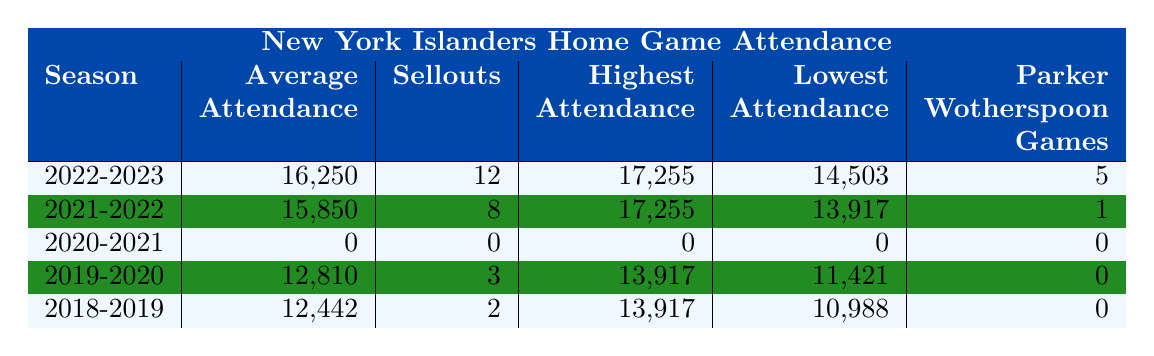What was the highest attendance at a New York Islanders home game over the last 5 seasons? By looking at the "Highest Attendance" column, the highest value listed is 17,255, which occurs in both the 2022-2023 and 2021-2022 seasons.
Answer: 17,255 In which season did the New York Islanders have the lowest average attendance? The "Average Attendance" column shows the values 16,250, 15,850, 0, 12,810, and 12,442. The lowest average attendance is 0 in the 2020-2021 season.
Answer: 2020-2021 How many sellouts did the Islanders achieve in the 2022-2023 season? The "Sellouts" column for the 2022-2023 season indicates there were 12 sellouts.
Answer: 12 What is the difference between the highest and lowest attendance figures in the 2019-2020 season? The "Highest Attendance" for 2019-2020 is 13,917 and the "Lowest Attendance" is 11,421. The difference is 13,917 - 11,421 = 2,496.
Answer: 2,496 Did the average attendance increase or decrease from the 2018-2019 season to the 2019-2020 season? In the 2018-2019 season, the average attendance was 12,442, while in the 2019-2020 season it decreased to 12,810. Since 12,810 is greater than 12,442, it decreased.
Answer: Decrease How many games did Parker Wotherspoon play in the seasons that recorded attendance? Summing the "Parker Wotherspoon Games" column for the seasons with attendance (2022-2023, 2021-2022, 2019-2020, and 2018-2019), we find 5 + 1 + 0 + 0 = 6 games.
Answer: 6 What was the average attendance across the five seasons? To find the average attendance, we calculate the total based on available data: (16,250 + 15,850 + 0 + 12,810 + 12,442) = 57,352. There are 4 instances (excluding the 2020-2021 season), so 57,352 / 4 = 14,338.
Answer: 14,338 Which season had the most games played by Parker Wotherspoon? Analyzing the "Parker Wotherspoon Games" column, the season with the highest value is 2022-2023, with 5 games.
Answer: 2022-2023 How many seasons had an average attendance of over 15,000? Counting the seasons with an average attendance greater than 15,000 reveals two seasons: 2022-2023 (16,250) and 2021-2022 (15,850).
Answer: 2 Is it true that the highest attendance figures were recorded in the same season for the last five seasons? By looking at the "Highest Attendance" figures, both the 2022-2023 and 2021-2022 seasons had the same highest attendance (17,255), so it is not true.
Answer: False What was the trend of sellouts from 2018-2019 to 2022-2023? The sellout numbers were as follows: 2 (2018-2019), 3 (2019-2020), 0 (2020-2021), 8 (2021-2022), and 12 (2022-2023). This indicates an increase over the period.
Answer: Increase 